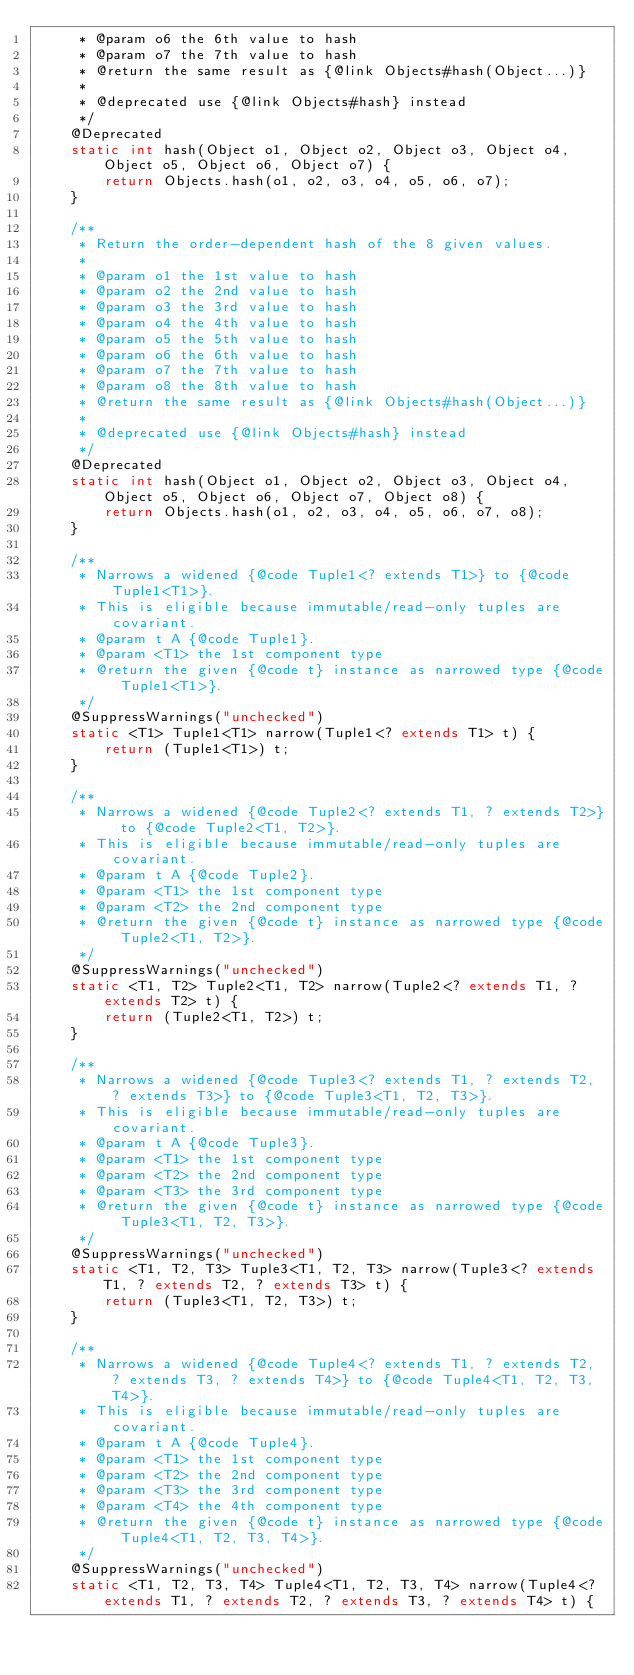<code> <loc_0><loc_0><loc_500><loc_500><_Java_>     * @param o6 the 6th value to hash
     * @param o7 the 7th value to hash
     * @return the same result as {@link Objects#hash(Object...)}
     *
     * @deprecated use {@link Objects#hash} instead
     */
    @Deprecated
    static int hash(Object o1, Object o2, Object o3, Object o4, Object o5, Object o6, Object o7) {
        return Objects.hash(o1, o2, o3, o4, o5, o6, o7);
    }

    /**
     * Return the order-dependent hash of the 8 given values.
     *
     * @param o1 the 1st value to hash
     * @param o2 the 2nd value to hash
     * @param o3 the 3rd value to hash
     * @param o4 the 4th value to hash
     * @param o5 the 5th value to hash
     * @param o6 the 6th value to hash
     * @param o7 the 7th value to hash
     * @param o8 the 8th value to hash
     * @return the same result as {@link Objects#hash(Object...)}
     *
     * @deprecated use {@link Objects#hash} instead
     */
    @Deprecated
    static int hash(Object o1, Object o2, Object o3, Object o4, Object o5, Object o6, Object o7, Object o8) {
        return Objects.hash(o1, o2, o3, o4, o5, o6, o7, o8);
    }

    /**
     * Narrows a widened {@code Tuple1<? extends T1>} to {@code Tuple1<T1>}.
     * This is eligible because immutable/read-only tuples are covariant.
     * @param t A {@code Tuple1}.
     * @param <T1> the 1st component type
     * @return the given {@code t} instance as narrowed type {@code Tuple1<T1>}.
     */
    @SuppressWarnings("unchecked")
    static <T1> Tuple1<T1> narrow(Tuple1<? extends T1> t) {
        return (Tuple1<T1>) t;
    }

    /**
     * Narrows a widened {@code Tuple2<? extends T1, ? extends T2>} to {@code Tuple2<T1, T2>}.
     * This is eligible because immutable/read-only tuples are covariant.
     * @param t A {@code Tuple2}.
     * @param <T1> the 1st component type
     * @param <T2> the 2nd component type
     * @return the given {@code t} instance as narrowed type {@code Tuple2<T1, T2>}.
     */
    @SuppressWarnings("unchecked")
    static <T1, T2> Tuple2<T1, T2> narrow(Tuple2<? extends T1, ? extends T2> t) {
        return (Tuple2<T1, T2>) t;
    }

    /**
     * Narrows a widened {@code Tuple3<? extends T1, ? extends T2, ? extends T3>} to {@code Tuple3<T1, T2, T3>}.
     * This is eligible because immutable/read-only tuples are covariant.
     * @param t A {@code Tuple3}.
     * @param <T1> the 1st component type
     * @param <T2> the 2nd component type
     * @param <T3> the 3rd component type
     * @return the given {@code t} instance as narrowed type {@code Tuple3<T1, T2, T3>}.
     */
    @SuppressWarnings("unchecked")
    static <T1, T2, T3> Tuple3<T1, T2, T3> narrow(Tuple3<? extends T1, ? extends T2, ? extends T3> t) {
        return (Tuple3<T1, T2, T3>) t;
    }

    /**
     * Narrows a widened {@code Tuple4<? extends T1, ? extends T2, ? extends T3, ? extends T4>} to {@code Tuple4<T1, T2, T3, T4>}.
     * This is eligible because immutable/read-only tuples are covariant.
     * @param t A {@code Tuple4}.
     * @param <T1> the 1st component type
     * @param <T2> the 2nd component type
     * @param <T3> the 3rd component type
     * @param <T4> the 4th component type
     * @return the given {@code t} instance as narrowed type {@code Tuple4<T1, T2, T3, T4>}.
     */
    @SuppressWarnings("unchecked")
    static <T1, T2, T3, T4> Tuple4<T1, T2, T3, T4> narrow(Tuple4<? extends T1, ? extends T2, ? extends T3, ? extends T4> t) {</code> 